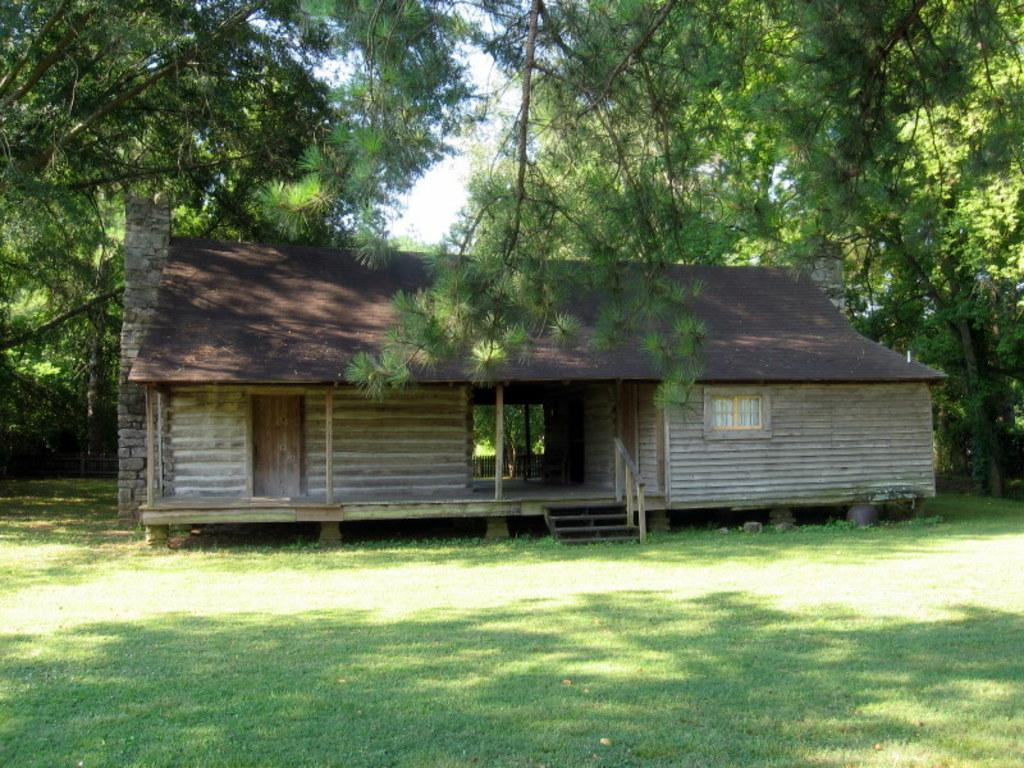What is the main structure in the image? There is a house in the middle of the image. What type of ground is visible in the image? There is grass on the ground. What can be seen in the background of the image? There are trees and the sky visible in the background of the image. What book is the baby reading in the image? There is no baby or book present in the image. 